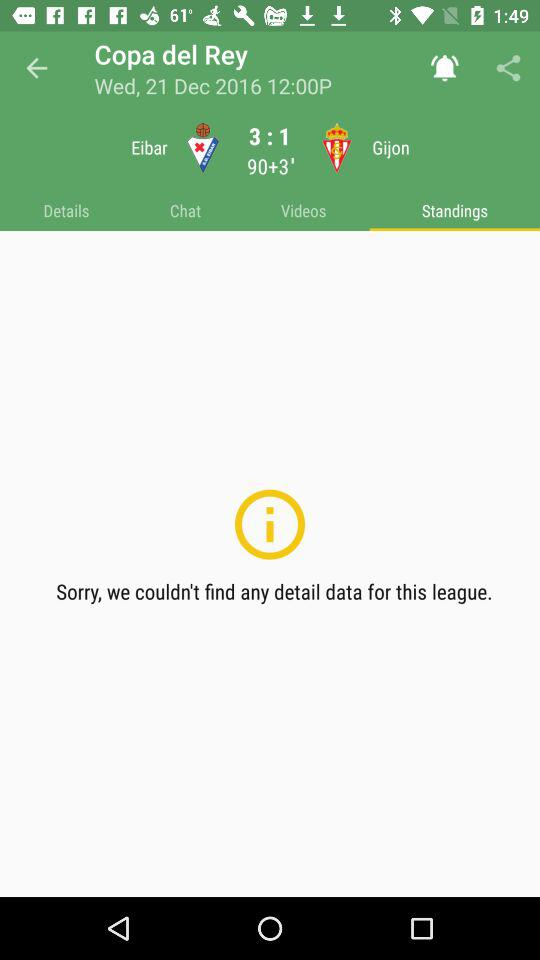What is the score for Köln vs Bayer Leverkusen? The score is 1:1. 